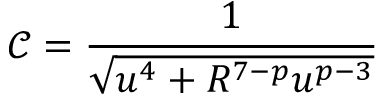Convert formula to latex. <formula><loc_0><loc_0><loc_500><loc_500>\mathcal { C } = \frac { 1 } { \sqrt { u ^ { 4 } + R ^ { 7 - p } u ^ { p - 3 } } }</formula> 